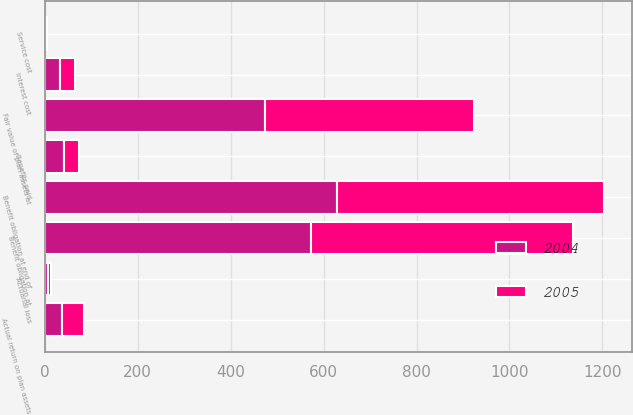Convert chart. <chart><loc_0><loc_0><loc_500><loc_500><stacked_bar_chart><ecel><fcel>Benefit obligation at<fcel>Service cost<fcel>Interest cost<fcel>Actuarial loss<fcel>Benefits paid<fcel>Benefit obligation at end of<fcel>Fair value of plan assets at<fcel>Actual return on plan assets<nl><fcel>2004<fcel>573<fcel>2.1<fcel>31.8<fcel>6.6<fcel>41.7<fcel>629.8<fcel>474.9<fcel>36.1<nl><fcel>2005<fcel>564.2<fcel>1.8<fcel>32.4<fcel>6.9<fcel>32.3<fcel>573<fcel>449.3<fcel>47.3<nl></chart> 